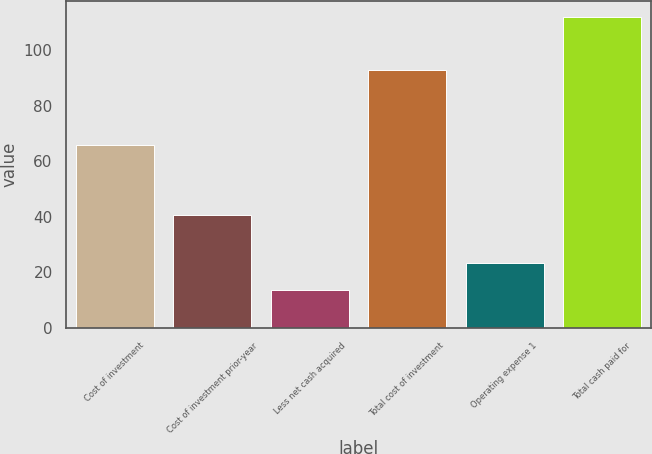<chart> <loc_0><loc_0><loc_500><loc_500><bar_chart><fcel>Cost of investment<fcel>Cost of investment prior-year<fcel>Less net cash acquired<fcel>Total cost of investment<fcel>Operating expense 1<fcel>Total cash paid for<nl><fcel>65.7<fcel>40.7<fcel>13.6<fcel>92.8<fcel>23.43<fcel>111.9<nl></chart> 